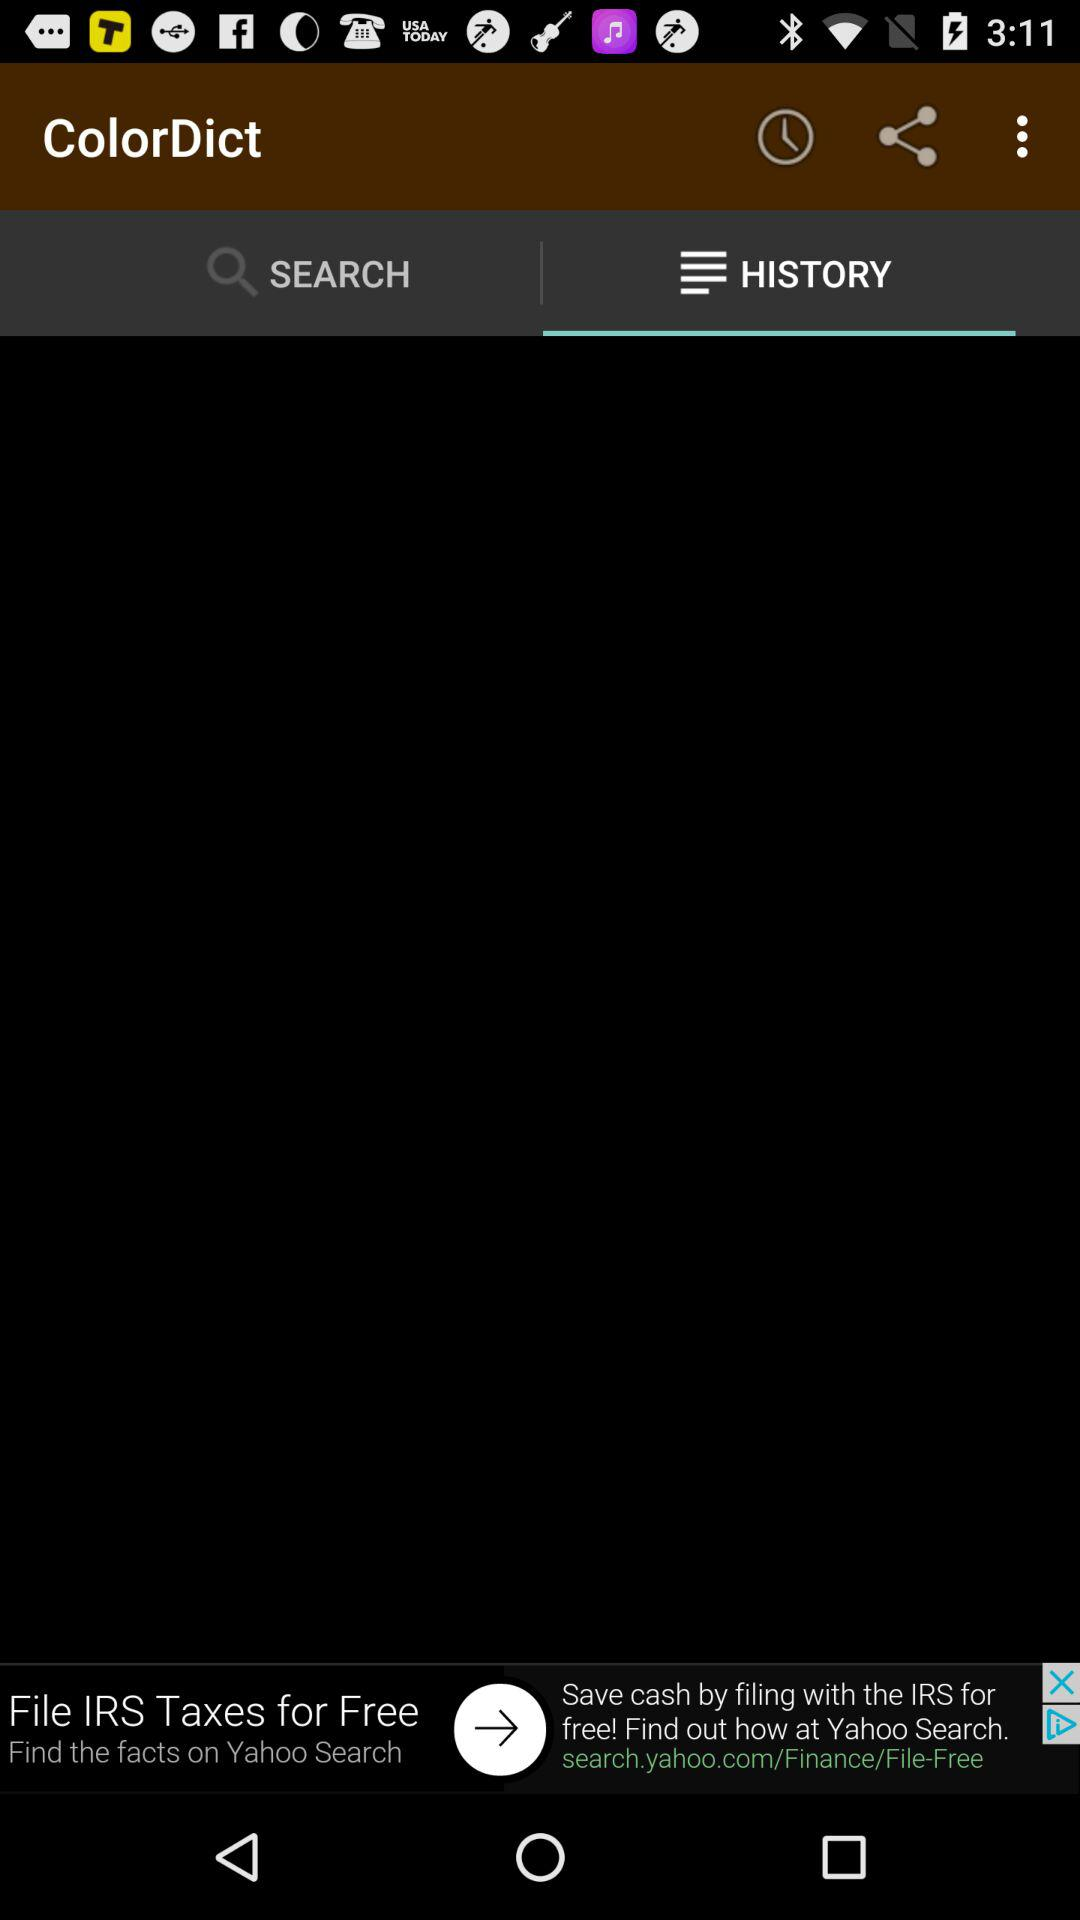What is the application name? The application name is "ColorDict". 